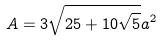Convert formula to latex. <formula><loc_0><loc_0><loc_500><loc_500>A = 3 \sqrt { 2 5 + 1 0 \sqrt { 5 } } a ^ { 2 }</formula> 